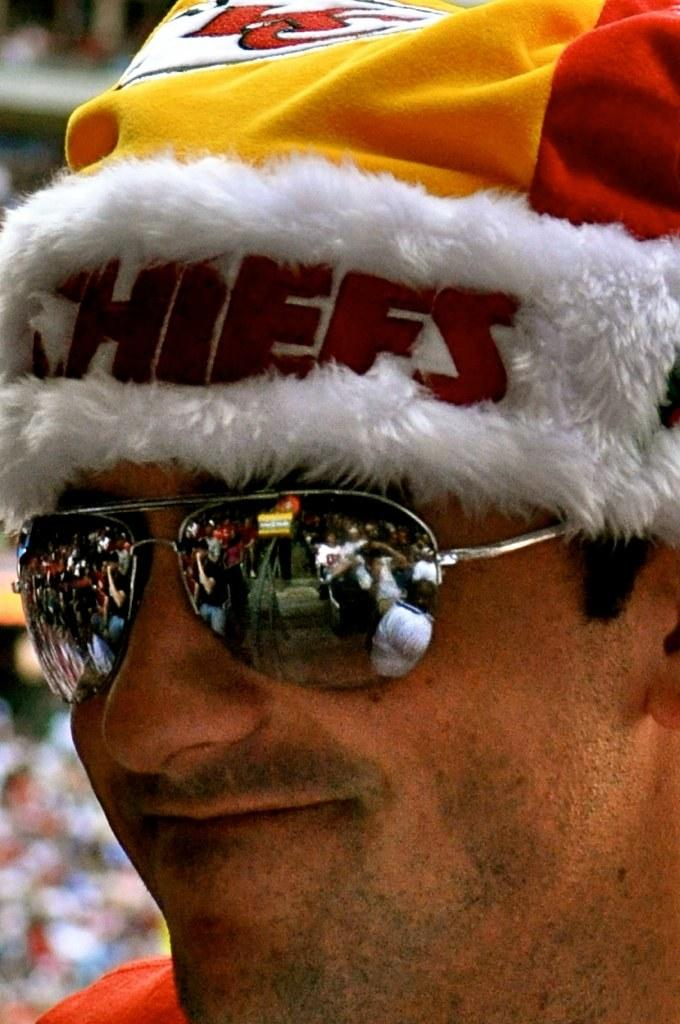What is the gender of the person in the image? The person in the image is a man. How much of the man's body is visible in the image? Only the man's face is visible in the image. What type of headwear is the man wearing? The man is wearing a cap. What type of eyewear is the man wearing? The man is wearing goggles. What type of snake is wrapped around the man's neck in the image? There is no snake present in the image; only the man's face, cap, and goggles are visible. 